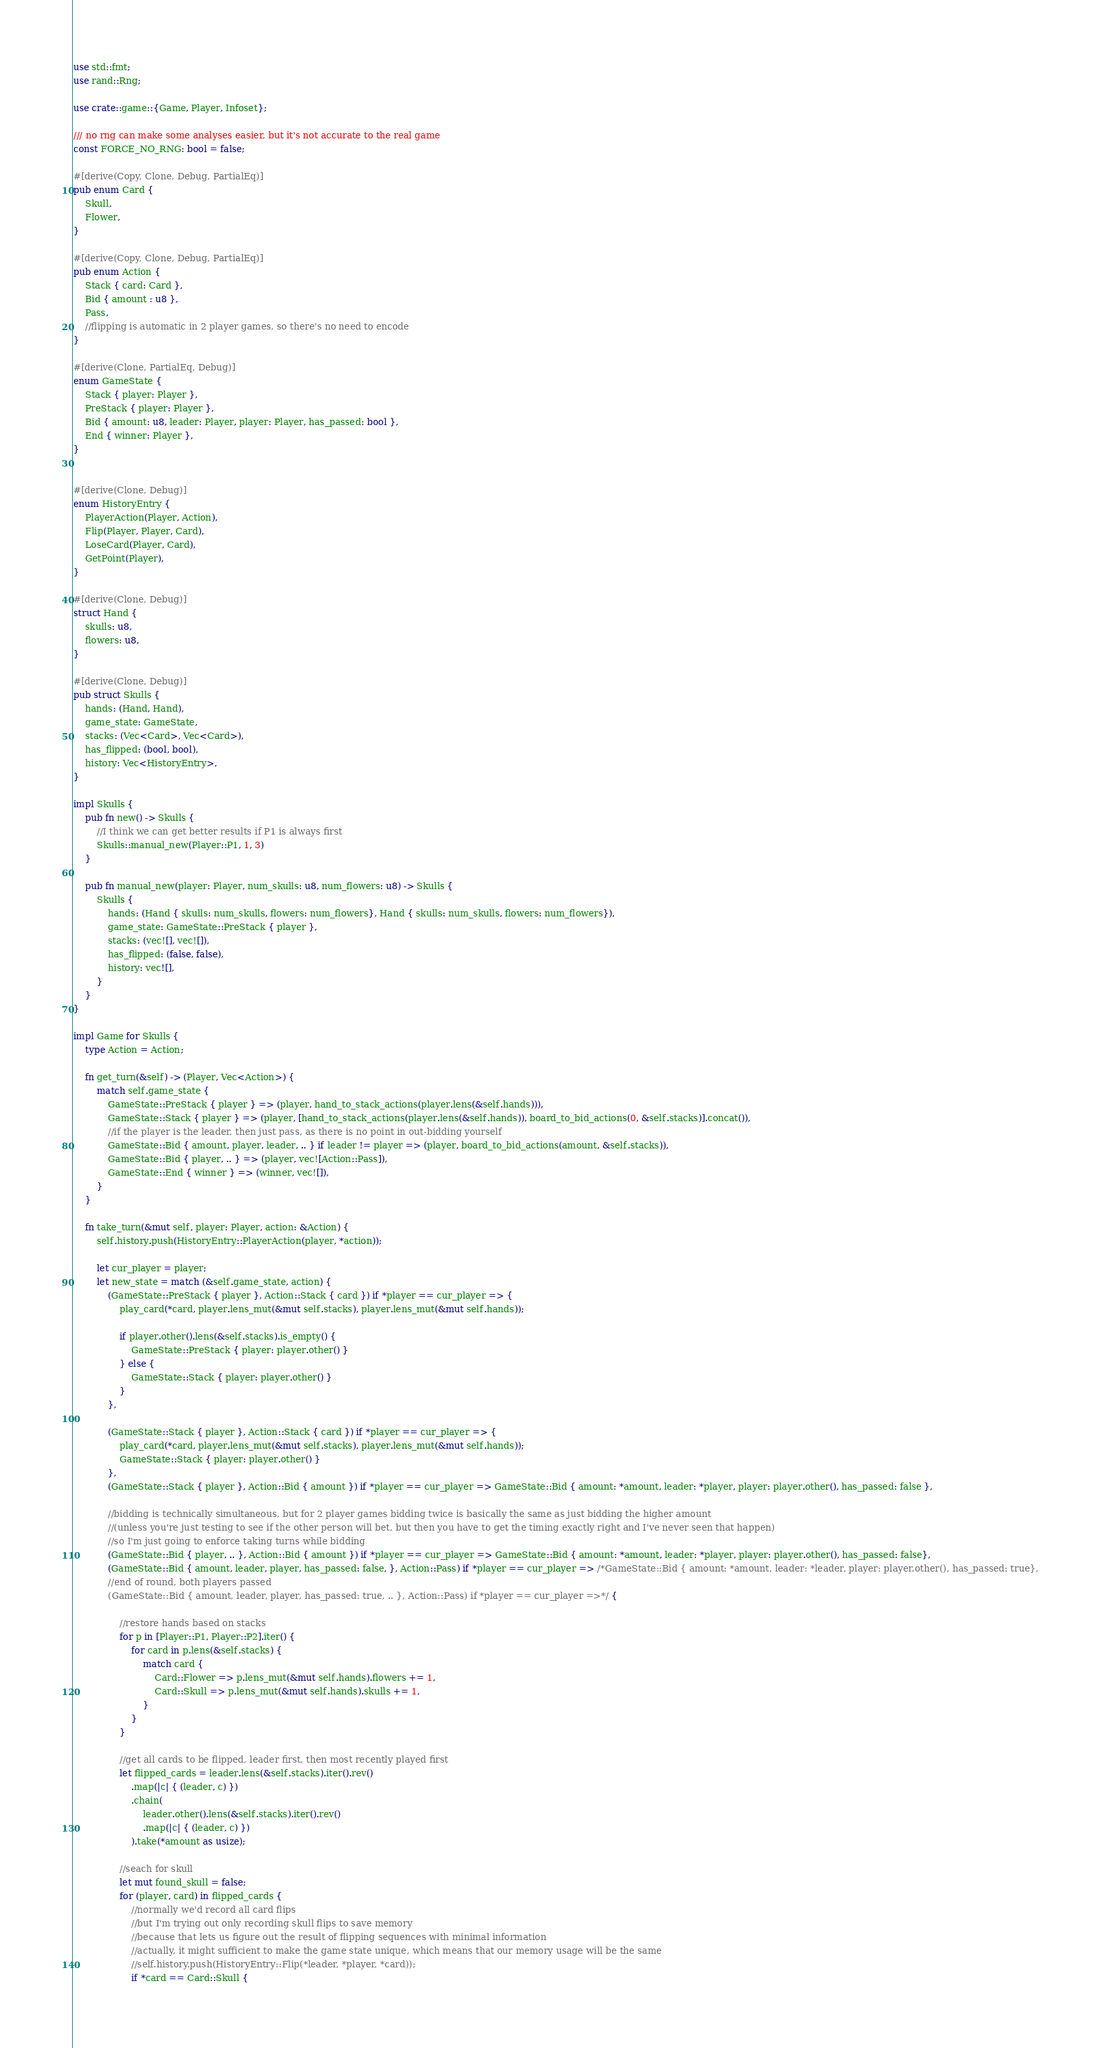Convert code to text. <code><loc_0><loc_0><loc_500><loc_500><_Rust_>use std::fmt;
use rand::Rng;

use crate::game::{Game, Player, Infoset};

/// no rng can make some analyses easier, but it's not accurate to the real game
const FORCE_NO_RNG: bool = false;

#[derive(Copy, Clone, Debug, PartialEq)]
pub enum Card {
    Skull,
    Flower,
}

#[derive(Copy, Clone, Debug, PartialEq)]
pub enum Action {
    Stack { card: Card },
    Bid { amount : u8 },
    Pass,
    //flipping is automatic in 2 player games, so there's no need to encode
}

#[derive(Clone, PartialEq, Debug)]
enum GameState {
    Stack { player: Player },
    PreStack { player: Player },
    Bid { amount: u8, leader: Player, player: Player, has_passed: bool },
    End { winner: Player },
}


#[derive(Clone, Debug)]
enum HistoryEntry {
    PlayerAction(Player, Action),
    Flip(Player, Player, Card),
    LoseCard(Player, Card),
    GetPoint(Player),
}

#[derive(Clone, Debug)]
struct Hand {
    skulls: u8,
    flowers: u8,
}

#[derive(Clone, Debug)]
pub struct Skulls {
    hands: (Hand, Hand),
    game_state: GameState,
    stacks: (Vec<Card>, Vec<Card>),
    has_flipped: (bool, bool),
    history: Vec<HistoryEntry>,
}

impl Skulls {
    pub fn new() -> Skulls {
        //I think we can get better results if P1 is always first
        Skulls::manual_new(Player::P1, 1, 3)
    }

    pub fn manual_new(player: Player, num_skulls: u8, num_flowers: u8) -> Skulls {
        Skulls {
            hands: (Hand { skulls: num_skulls, flowers: num_flowers}, Hand { skulls: num_skulls, flowers: num_flowers}),
            game_state: GameState::PreStack { player },
            stacks: (vec![], vec![]),
            has_flipped: (false, false),
            history: vec![],
        }
    }
}

impl Game for Skulls {
    type Action = Action;

    fn get_turn(&self) -> (Player, Vec<Action>) {
        match self.game_state {
            GameState::PreStack { player } => (player, hand_to_stack_actions(player.lens(&self.hands))),
            GameState::Stack { player } => (player, [hand_to_stack_actions(player.lens(&self.hands)), board_to_bid_actions(0, &self.stacks)].concat()),
            //if the player is the leader, then just pass, as there is no point in out-bidding yourself
            GameState::Bid { amount, player, leader, .. } if leader != player => (player, board_to_bid_actions(amount, &self.stacks)),
            GameState::Bid { player, .. } => (player, vec![Action::Pass]),
            GameState::End { winner } => (winner, vec![]),
        }
    }

    fn take_turn(&mut self, player: Player, action: &Action) {
        self.history.push(HistoryEntry::PlayerAction(player, *action));

        let cur_player = player;
        let new_state = match (&self.game_state, action) {
            (GameState::PreStack { player }, Action::Stack { card }) if *player == cur_player => {
                play_card(*card, player.lens_mut(&mut self.stacks), player.lens_mut(&mut self.hands));

                if player.other().lens(&self.stacks).is_empty() {
                    GameState::PreStack { player: player.other() }
                } else {
                    GameState::Stack { player: player.other() }
                }
            },

            (GameState::Stack { player }, Action::Stack { card }) if *player == cur_player => {
                play_card(*card, player.lens_mut(&mut self.stacks), player.lens_mut(&mut self.hands));
                GameState::Stack { player: player.other() }
            },
            (GameState::Stack { player }, Action::Bid { amount }) if *player == cur_player => GameState::Bid { amount: *amount, leader: *player, player: player.other(), has_passed: false },

            //bidding is technically simultaneous, but for 2 player games bidding twice is basically the same as just bidding the higher amount
            //(unless you're just testing to see if the other person will bet, but then you have to get the timing exactly right and I've never seen that happen)
            //so I'm just going to enforce taking turns while bidding
            (GameState::Bid { player, .. }, Action::Bid { amount }) if *player == cur_player => GameState::Bid { amount: *amount, leader: *player, player: player.other(), has_passed: false},
            (GameState::Bid { amount, leader, player, has_passed: false, }, Action::Pass) if *player == cur_player => /*GameState::Bid { amount: *amount, leader: *leader, player: player.other(), has_passed: true},
            //end of round, both players passed
            (GameState::Bid { amount, leader, player, has_passed: true, .. }, Action::Pass) if *player == cur_player =>*/ {

                //restore hands based on stacks
                for p in [Player::P1, Player::P2].iter() {
                    for card in p.lens(&self.stacks) {
                        match card {
                            Card::Flower => p.lens_mut(&mut self.hands).flowers += 1,
                            Card::Skull => p.lens_mut(&mut self.hands).skulls += 1,
                        }
                    }
                }

                //get all cards to be flipped, leader first, then most recently played first
                let flipped_cards = leader.lens(&self.stacks).iter().rev()
                    .map(|c| { (leader, c) })
                    .chain(
                        leader.other().lens(&self.stacks).iter().rev()
                        .map(|c| { (leader, c) })
                    ).take(*amount as usize);
                
                //seach for skull
                let mut found_skull = false;
                for (player, card) in flipped_cards {
                    //normally we'd record all card flips
                    //but I'm trying out only recording skull flips to save memory
                    //because that lets us figure out the result of flipping sequences with minimal information
                    //actually, it might sufficient to make the game state unique, which means that our memory usage will be the same
                    //self.history.push(HistoryEntry::Flip(*leader, *player, *card));
                    if *card == Card::Skull {</code> 